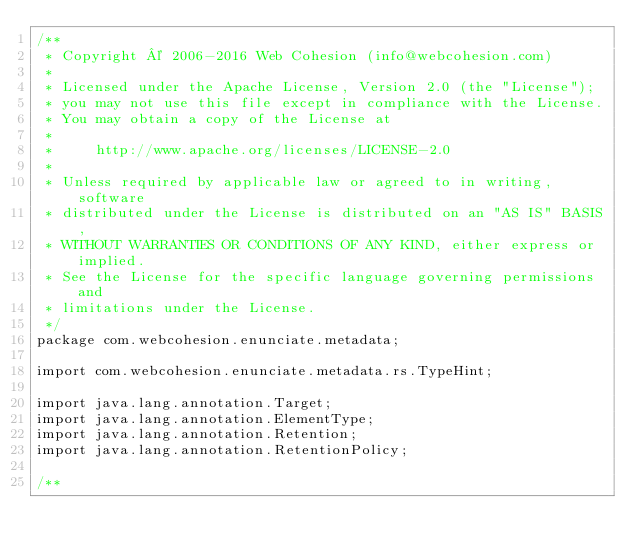Convert code to text. <code><loc_0><loc_0><loc_500><loc_500><_Java_>/**
 * Copyright © 2006-2016 Web Cohesion (info@webcohesion.com)
 *
 * Licensed under the Apache License, Version 2.0 (the "License");
 * you may not use this file except in compliance with the License.
 * You may obtain a copy of the License at
 *
 *     http://www.apache.org/licenses/LICENSE-2.0
 *
 * Unless required by applicable law or agreed to in writing, software
 * distributed under the License is distributed on an "AS IS" BASIS,
 * WITHOUT WARRANTIES OR CONDITIONS OF ANY KIND, either express or implied.
 * See the License for the specific language governing permissions and
 * limitations under the License.
 */
package com.webcohesion.enunciate.metadata;

import com.webcohesion.enunciate.metadata.rs.TypeHint;

import java.lang.annotation.Target;
import java.lang.annotation.ElementType;
import java.lang.annotation.Retention;
import java.lang.annotation.RetentionPolicy;

/**</code> 